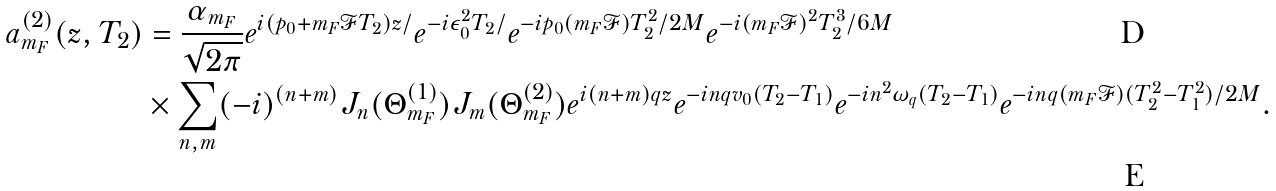<formula> <loc_0><loc_0><loc_500><loc_500>a _ { m _ { F } } ^ { ( 2 ) } ( z , T _ { 2 } ) & = \frac { \alpha _ { m _ { F } } } { \sqrt { 2 \pi } } e ^ { i ( p _ { 0 } + m _ { F } \mathcal { F } T _ { 2 } ) z / } e ^ { - i \epsilon _ { 0 } ^ { 2 } T _ { 2 } / } e ^ { - i p _ { 0 } ( m _ { F } \mathcal { F } ) T _ { 2 } ^ { 2 } / 2 M } e ^ { - i ( m _ { F } \mathcal { F } ) ^ { 2 } T _ { 2 } ^ { 3 } / 6 M } \\ & \times \sum _ { n , m } ( - i ) ^ { ( n + m ) } J _ { n } ( \Theta _ { m _ { F } } ^ { ( 1 ) } ) J _ { m } ( \Theta _ { m _ { F } } ^ { ( 2 ) } ) e ^ { i ( n + m ) q z } e ^ { - i n q v _ { 0 } ( T _ { 2 } - T _ { 1 } ) } e ^ { - i n ^ { 2 } \omega _ { q } ( T _ { 2 } - T _ { 1 } ) } e ^ { - i n q ( m _ { F } \mathcal { F } ) ( T _ { 2 } ^ { 2 } - T _ { 1 } ^ { 2 } ) / 2 M } .</formula> 